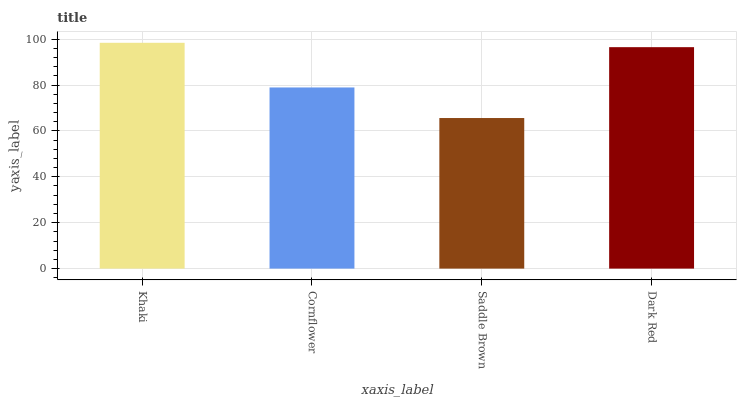Is Saddle Brown the minimum?
Answer yes or no. Yes. Is Khaki the maximum?
Answer yes or no. Yes. Is Cornflower the minimum?
Answer yes or no. No. Is Cornflower the maximum?
Answer yes or no. No. Is Khaki greater than Cornflower?
Answer yes or no. Yes. Is Cornflower less than Khaki?
Answer yes or no. Yes. Is Cornflower greater than Khaki?
Answer yes or no. No. Is Khaki less than Cornflower?
Answer yes or no. No. Is Dark Red the high median?
Answer yes or no. Yes. Is Cornflower the low median?
Answer yes or no. Yes. Is Khaki the high median?
Answer yes or no. No. Is Saddle Brown the low median?
Answer yes or no. No. 